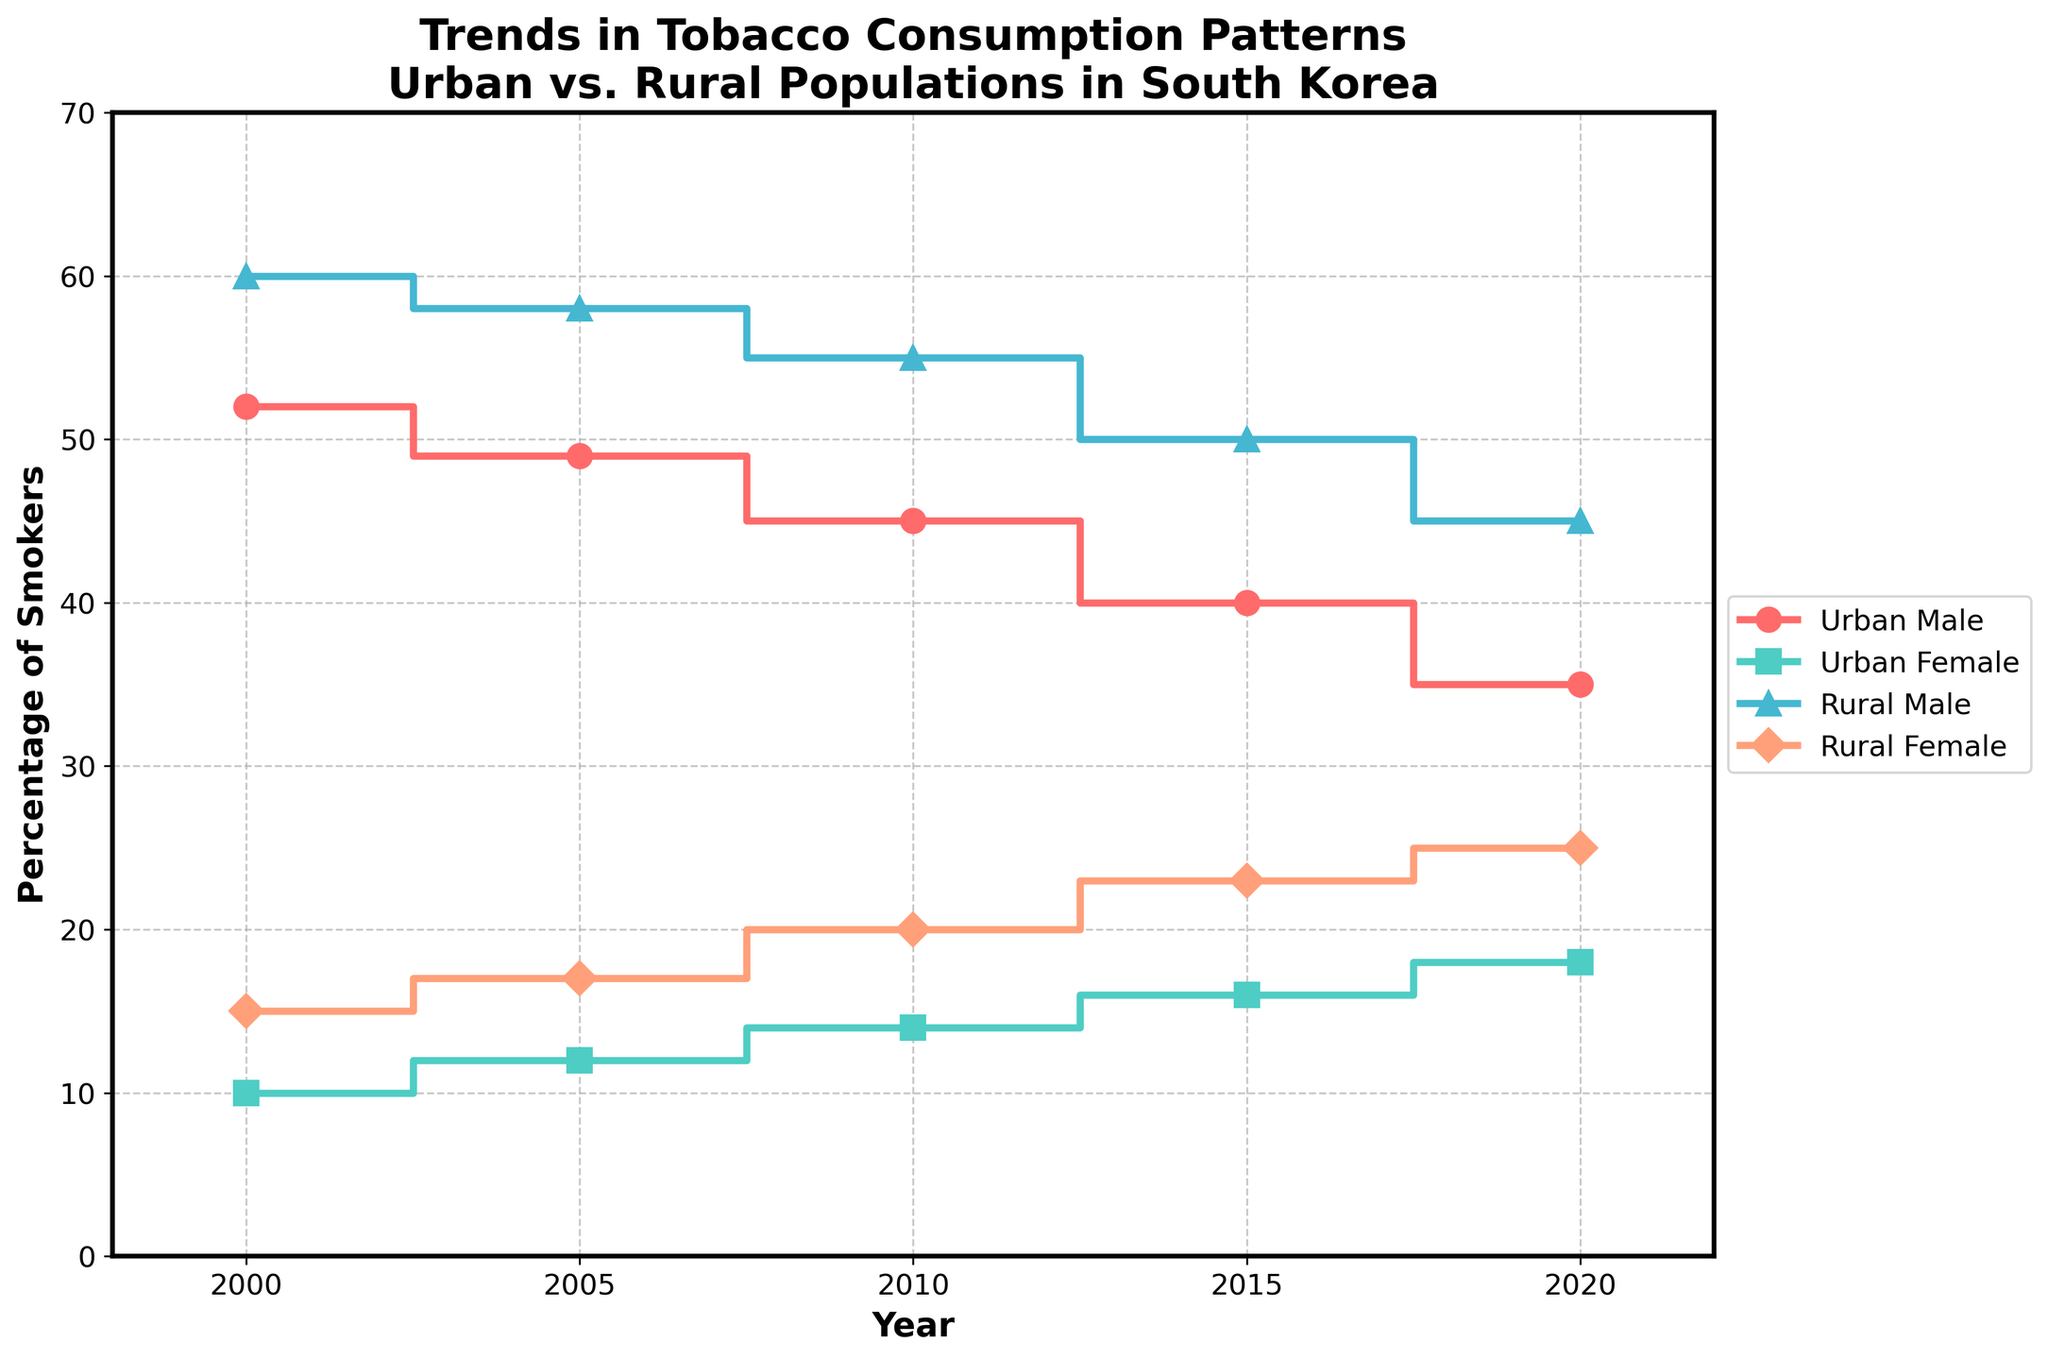What is the title of the figure? The title of the figure is located at the top of the chart. It reads "Trends in Tobacco Consumption Patterns Urban vs. Rural Populations in South Korea".
Answer: Trends in Tobacco Consumption Patterns Urban vs. Rural Populations in South Korea What does the x-axis represent? The x-axis represents the time period, which is indicated by years from 2000 to 2020.
Answer: Year How many data points are there for Urban Male Smokers? The number of data points can be counted by looking at the markers along the urban male smokers' line. There are 5 markers, corresponding to the years listed.
Answer: 5 What color represents Rural Female Smokers? The color that represents Rural Female Smokers can be identified by looking at the legend. Rural Female Smokers are represented by a salmon-like color.
Answer: Salmon Which group had the highest percentage of smokers in 2005 and what was this percentage? To find the group with the highest percentage of smokers in 2005, locate 2005 on the x-axis and refer to the values on the y-axis for each group. Rural Male Smokers had the highest percentage with 58%.
Answer: Rural Male Smokers, 58% How did the percentage of Urban Female Smokers change from 2000 to 2020? To find the change in percentage for Urban Female Smokers between 2000 and 2020, subtract the value in 2000 (10%) from the value in 2020 (18%). The change is 18% - 10% = 8%.
Answer: 8% Which group shows the steepest decline in smoking rates? To determine the group with the steepest decline, compare the downward trends of each group visually. The Urban Male Smokers' line shows the steepest decline from 52% in 2000 to 35% in 2020, a change of 17%.
Answer: Urban Male Smokers Who has a higher smoking rate in 2010, Urban Male Smokers or Rural Female Smokers? By locating the year 2010 on the x-axis and comparing the y-values for Urban Male Smokers and Rural Female Smokers, Urban Male Smokers have a higher rate with 45% compared to Rural Female Smokers with 20%.
Answer: Urban Male Smokers Between which two years did Rural Female Smokers see the highest increase in smoking rates? By examining the steps in the line for Rural Female Smokers, the highest increase occurs between 2000 and 2005 with an increase from 15% to 17% and from 2015 to 2020 with 23% to 25%. Both represent an increase of 2%, but the initial analysis should look at each interval. Further investigation will show 2005 and 2010 show an increase of 3%.
Answer: 2005 to 2010 Which year did Urban Male Smokers and Rural Male Smokers diverge the most, and what was the difference in percentage? To find the year with the greatest divergence, check the y-values for Urban Male Smokers and Rural Male Smokers for each year. In 2000, Urban Male Smokers were 52% and Rural Male Smokers were 60%, the difference is 8%.
Answer: 2000, 8% 